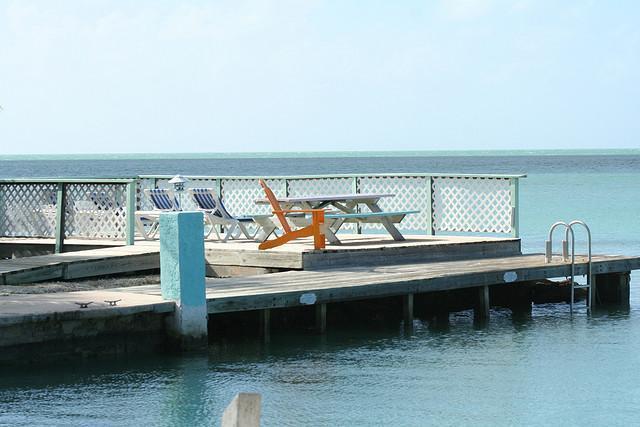How many airplanes do you see?
Give a very brief answer. 0. 